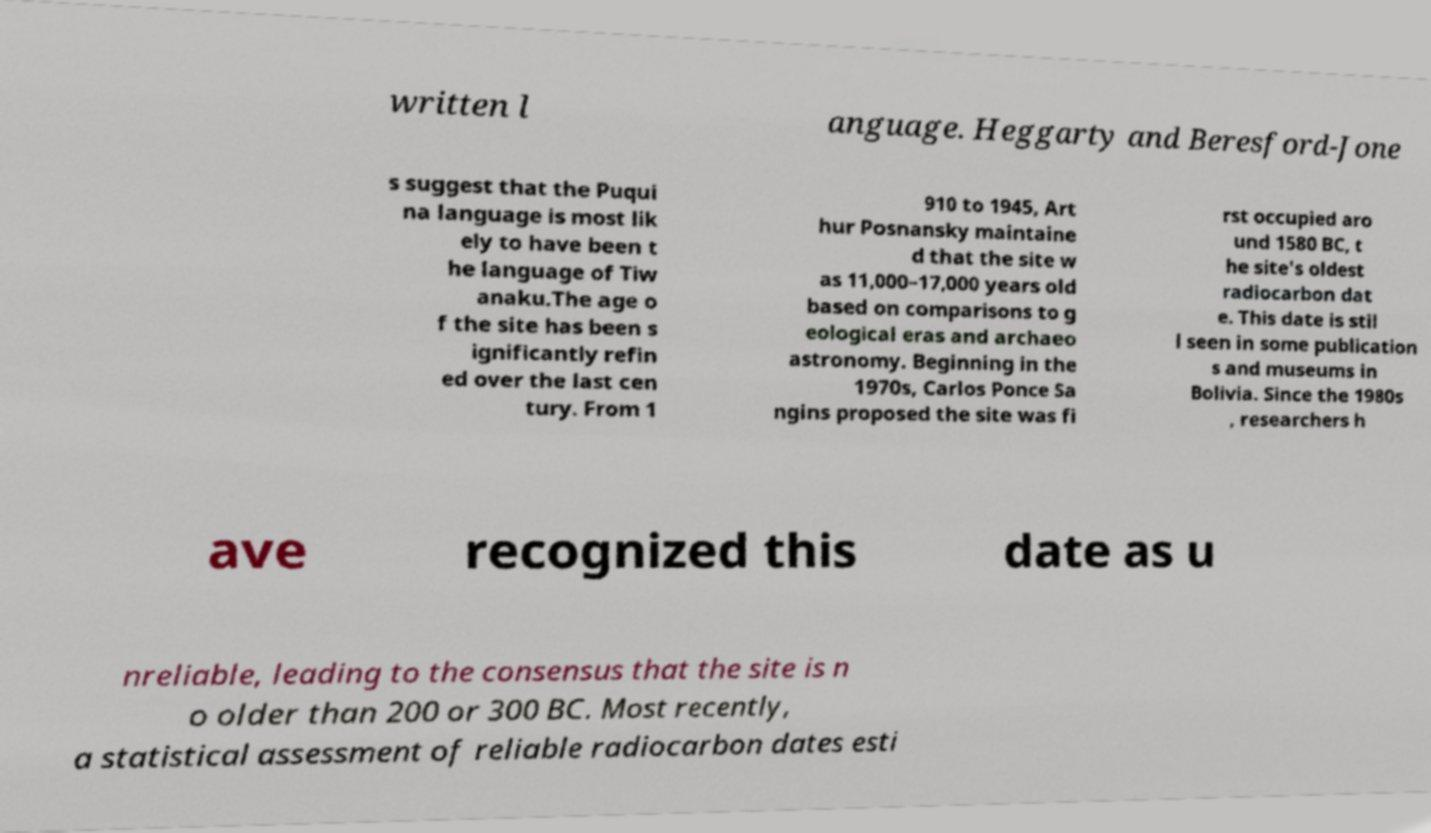Please identify and transcribe the text found in this image. written l anguage. Heggarty and Beresford-Jone s suggest that the Puqui na language is most lik ely to have been t he language of Tiw anaku.The age o f the site has been s ignificantly refin ed over the last cen tury. From 1 910 to 1945, Art hur Posnansky maintaine d that the site w as 11,000–17,000 years old based on comparisons to g eological eras and archaeo astronomy. Beginning in the 1970s, Carlos Ponce Sa ngins proposed the site was fi rst occupied aro und 1580 BC, t he site's oldest radiocarbon dat e. This date is stil l seen in some publication s and museums in Bolivia. Since the 1980s , researchers h ave recognized this date as u nreliable, leading to the consensus that the site is n o older than 200 or 300 BC. Most recently, a statistical assessment of reliable radiocarbon dates esti 